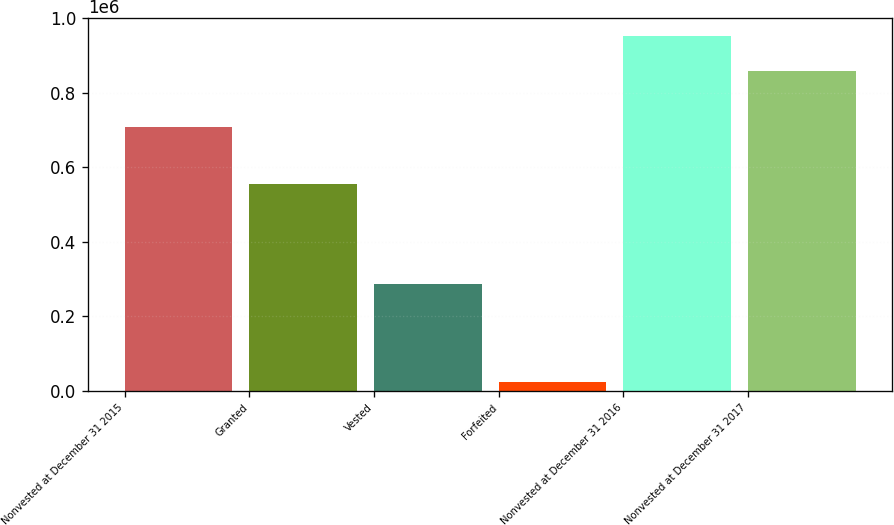Convert chart. <chart><loc_0><loc_0><loc_500><loc_500><bar_chart><fcel>Nonvested at December 31 2015<fcel>Granted<fcel>Vested<fcel>Forfeited<fcel>Nonvested at December 31 2016<fcel>Nonvested at December 31 2017<nl><fcel>709275<fcel>555730<fcel>287233<fcel>25100<fcel>952672<fcel>858996<nl></chart> 